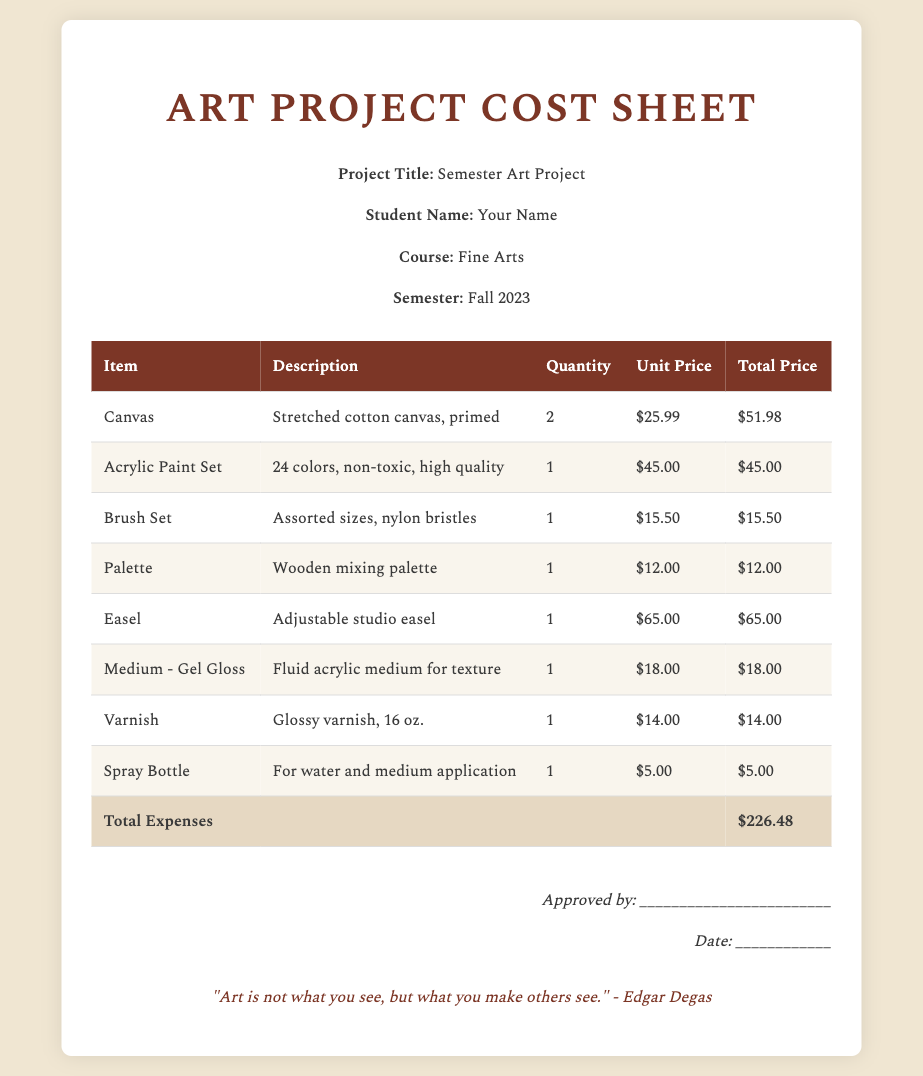what is the project title? The project title is specified in the document under the header information, which is "Semester Art Project."
Answer: Semester Art Project who is the student name? The student name is mentioned in the document under the header information, given as "Your Name."
Answer: Your Name how many canvases are listed? The quantity of canvases is indicated in the itemized list of expenses, which states "2."
Answer: 2 what is the total price for the acrylic paint set? The total price for the acrylic paint set is found in the table, which shows "$45.00."
Answer: $45.00 what is the total expenses amount? The total expenses amount is located at the bottom of the table, totaling to "$226.48."
Answer: $226.48 which item has the highest unit price? By reviewing the item list, the "Easel" has the highest unit price of "$65.00."
Answer: Easel how many items are there in total? The total number of items can be determined by counting the listed items in the table, which shows "8."
Answer: 8 what is the description of the brush set? The brush set's description is found in the table, stating "Assorted sizes, nylon bristles."
Answer: Assorted sizes, nylon bristles who is the quote attributed to? The quote at the bottom of the document is attributed to "Edgar Degas."
Answer: Edgar Degas when is the semester mentioned? The semester is specified in the header information as "Fall 2023."
Answer: Fall 2023 